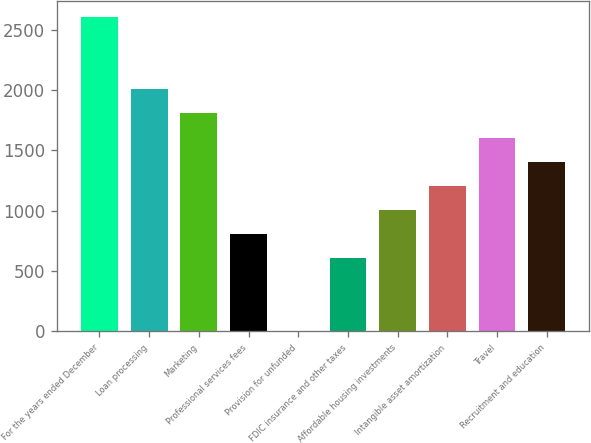<chart> <loc_0><loc_0><loc_500><loc_500><bar_chart><fcel>For the years ended December<fcel>Loan processing<fcel>Marketing<fcel>Professional services fees<fcel>Provision for unfunded<fcel>FDIC insurance and other taxes<fcel>Affordable housing investments<fcel>Intangible asset amortization<fcel>Travel<fcel>Recruitment and education<nl><fcel>2606.3<fcel>2006<fcel>1805.9<fcel>805.4<fcel>5<fcel>605.3<fcel>1005.5<fcel>1205.6<fcel>1605.8<fcel>1405.7<nl></chart> 